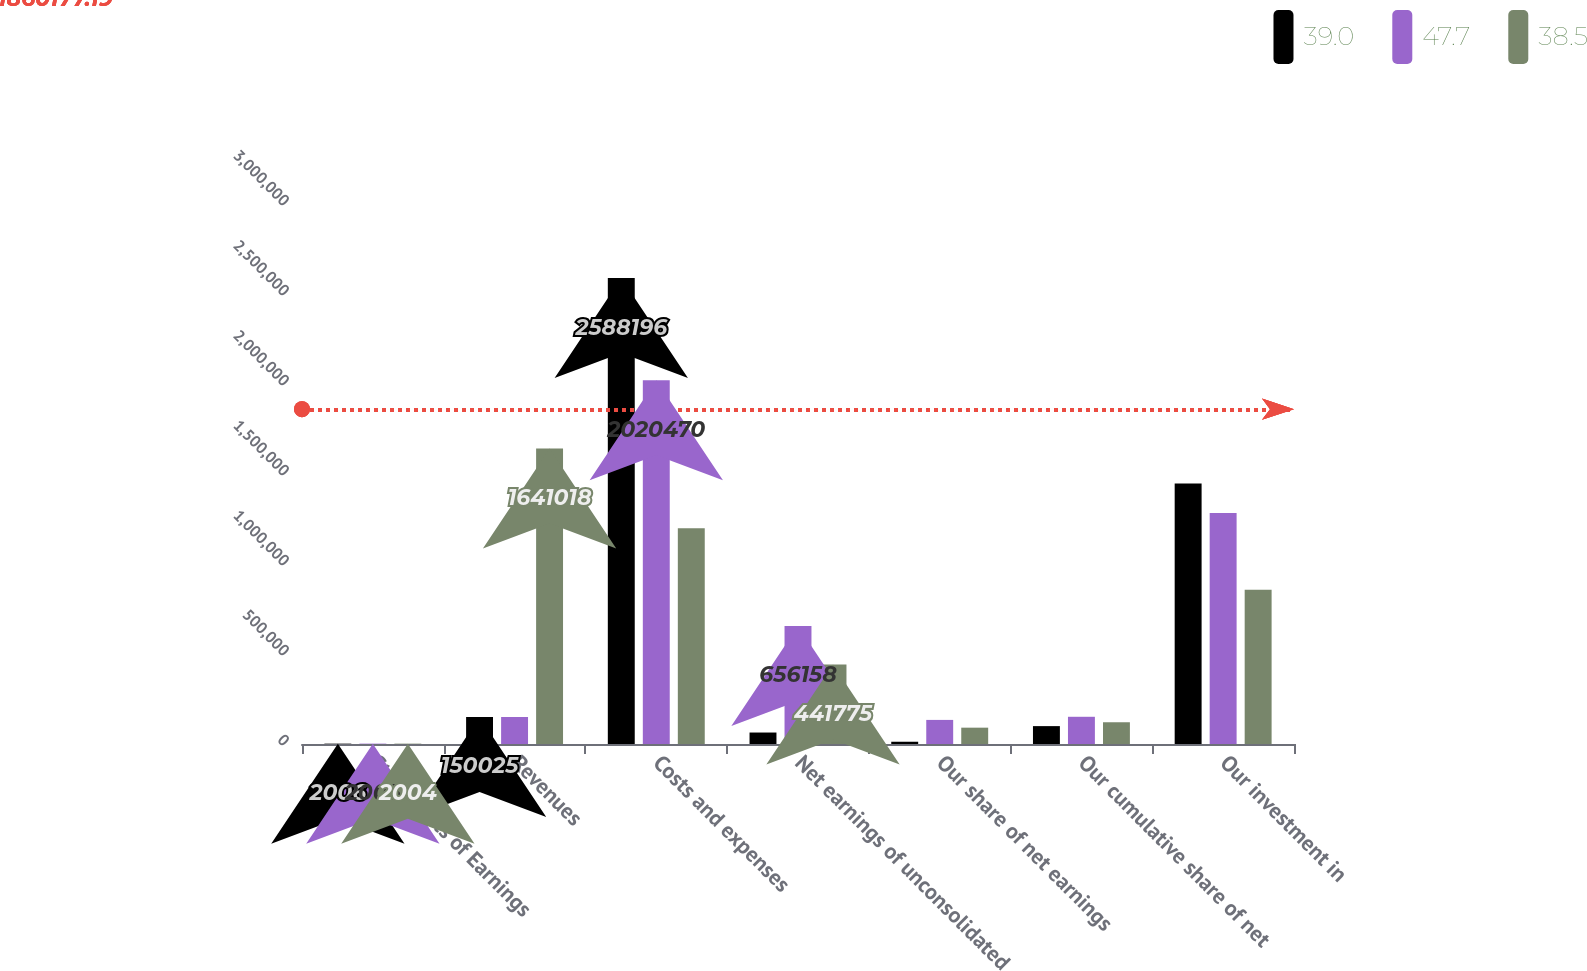Convert chart to OTSL. <chart><loc_0><loc_0><loc_500><loc_500><stacked_bar_chart><ecel><fcel>Statements of Earnings<fcel>Revenues<fcel>Costs and expenses<fcel>Net earnings of unconsolidated<fcel>Our share of net earnings<fcel>Our cumulative share of net<fcel>Our investment in<nl><fcel>39<fcel>2006<fcel>150025<fcel>2.5882e+06<fcel>63736<fcel>12536<fcel>99360<fcel>1.44718e+06<nl><fcel>47.7<fcel>2005<fcel>150025<fcel>2.02047e+06<fcel>656158<fcel>133814<fcel>151182<fcel>1.28269e+06<nl><fcel>38.5<fcel>2004<fcel>1.64102e+06<fcel>1.19924e+06<fcel>441775<fcel>90739<fcel>120817<fcel>856422<nl></chart> 